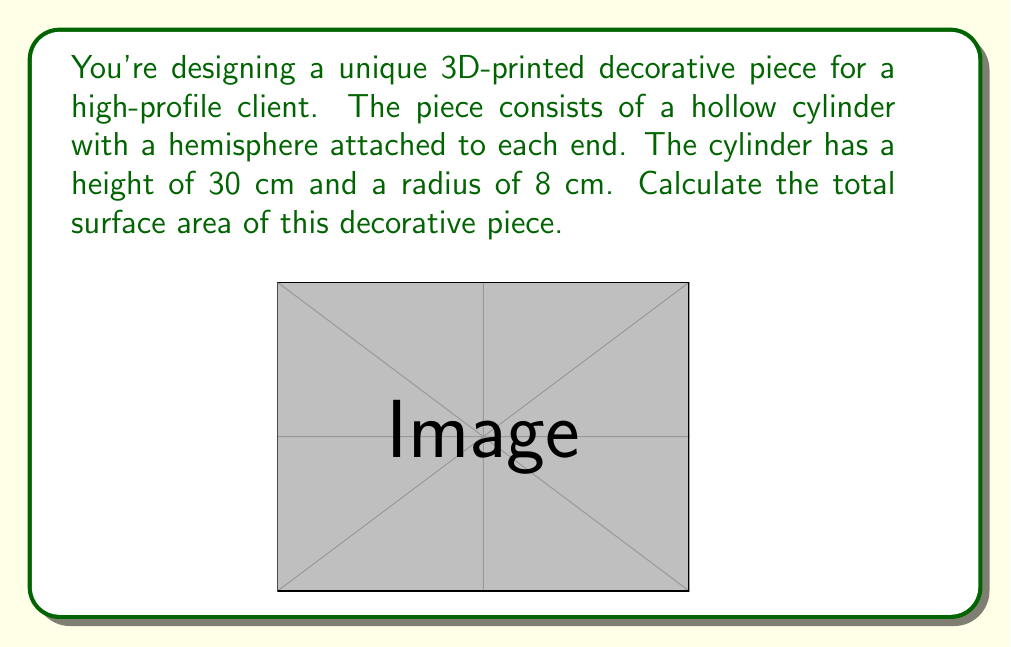Solve this math problem. To calculate the total surface area, we need to consider three parts:
1. The curved surface area of the cylinder
2. The surface area of the two hemispheres

Let's break it down step by step:

1. Curved surface area of the cylinder:
   $$ A_{cylinder} = 2\pi rh $$
   where $r$ is the radius and $h$ is the height
   $$ A_{cylinder} = 2\pi(8)(30) = 480\pi \text{ cm}^2 $$

2. Surface area of one hemisphere:
   $$ A_{hemisphere} = 2\pi r^2 $$
   $$ A_{hemisphere} = 2\pi(8^2) = 128\pi \text{ cm}^2 $$

   For two hemispheres:
   $$ A_{hemispheres} = 2(128\pi) = 256\pi \text{ cm}^2 $$

3. Total surface area:
   $$ A_{total} = A_{cylinder} + A_{hemispheres} $$
   $$ A_{total} = 480\pi + 256\pi = 736\pi \text{ cm}^2 $$

Therefore, the total surface area of the decorative piece is $736\pi \text{ cm}^2$ or approximately 2,311.54 cm².
Answer: $736\pi \text{ cm}^2$ or approximately 2,311.54 cm² 